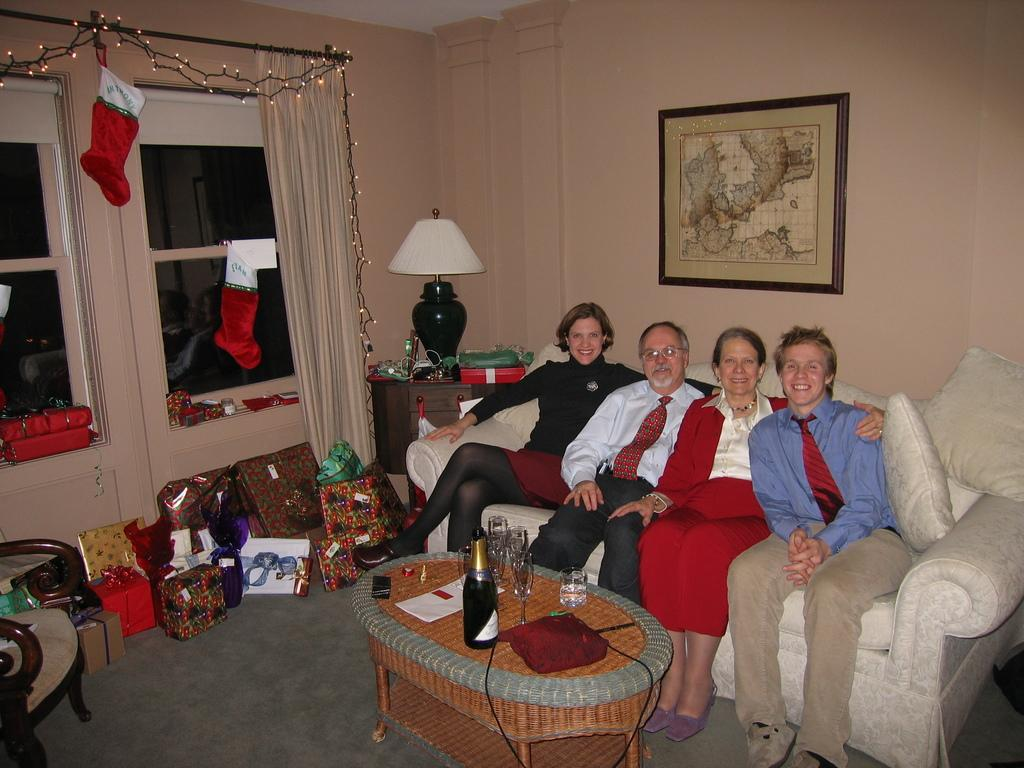How many people are sitting on the white sofa in the image? There are four people sitting on the white sofa in the image. What is located in front of the sofa? There is a table in front of the sofa. What can be seen on the table? The table has a wine bottle on it and glasses. What else is visible near the people on the sofa? There are gifts beside the people. What type of railway is visible in the image? There is no railway present in the image. How many chickens are sitting on the sofa with the people? There are no chickens present in the image; only people are sitting on the sofa. 